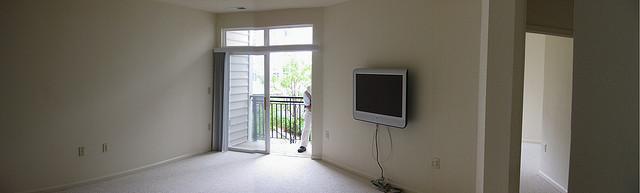How many red bags are in the picture?
Give a very brief answer. 0. 